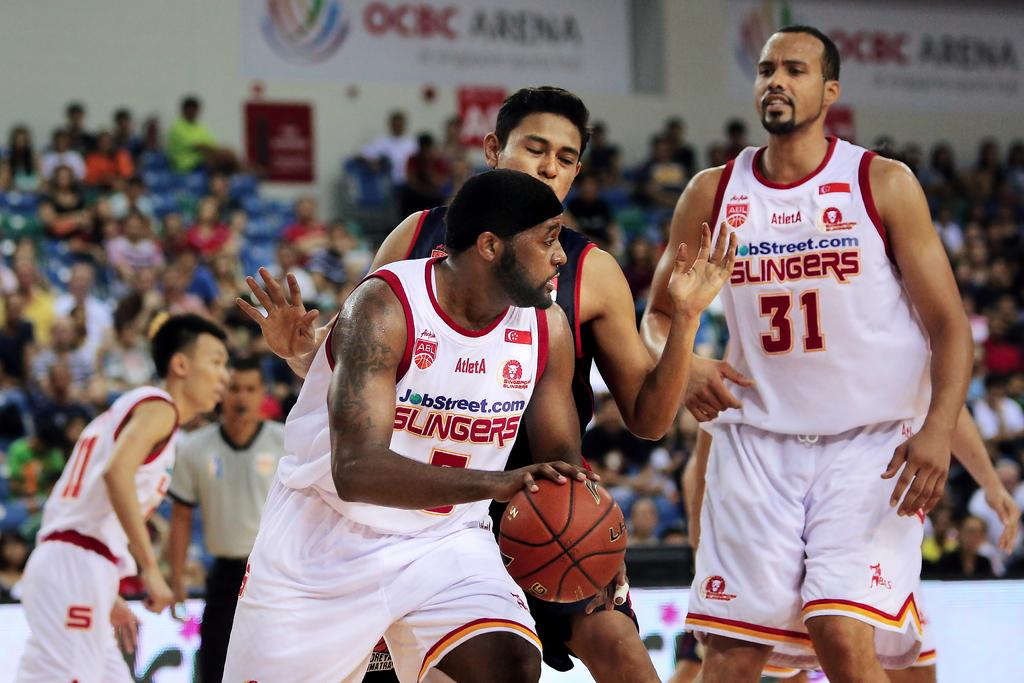<image>
Summarize the visual content of the image. basketball players with one wearing the number 31 jersy 